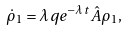Convert formula to latex. <formula><loc_0><loc_0><loc_500><loc_500>\dot { \rho } _ { 1 } = \lambda q e ^ { - \lambda t } \hat { A } \rho _ { 1 } ,</formula> 